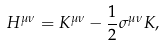<formula> <loc_0><loc_0><loc_500><loc_500>H ^ { \mu \nu } = K ^ { \mu \nu } - \frac { 1 } { 2 } \sigma ^ { \mu \nu } K ,</formula> 